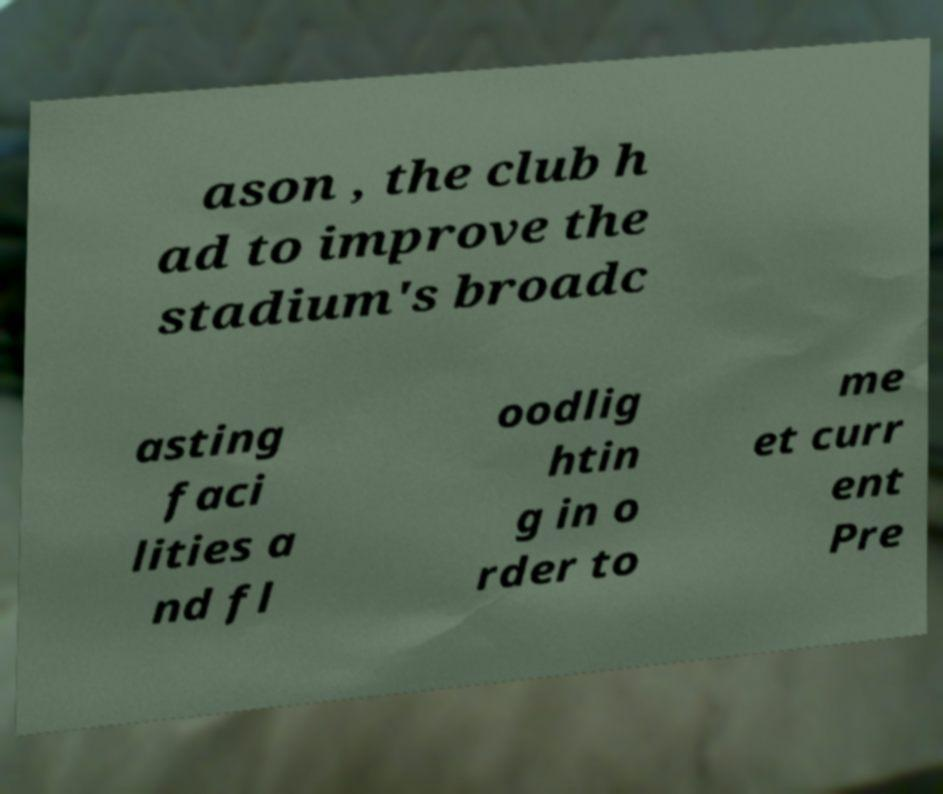Could you extract and type out the text from this image? ason , the club h ad to improve the stadium's broadc asting faci lities a nd fl oodlig htin g in o rder to me et curr ent Pre 